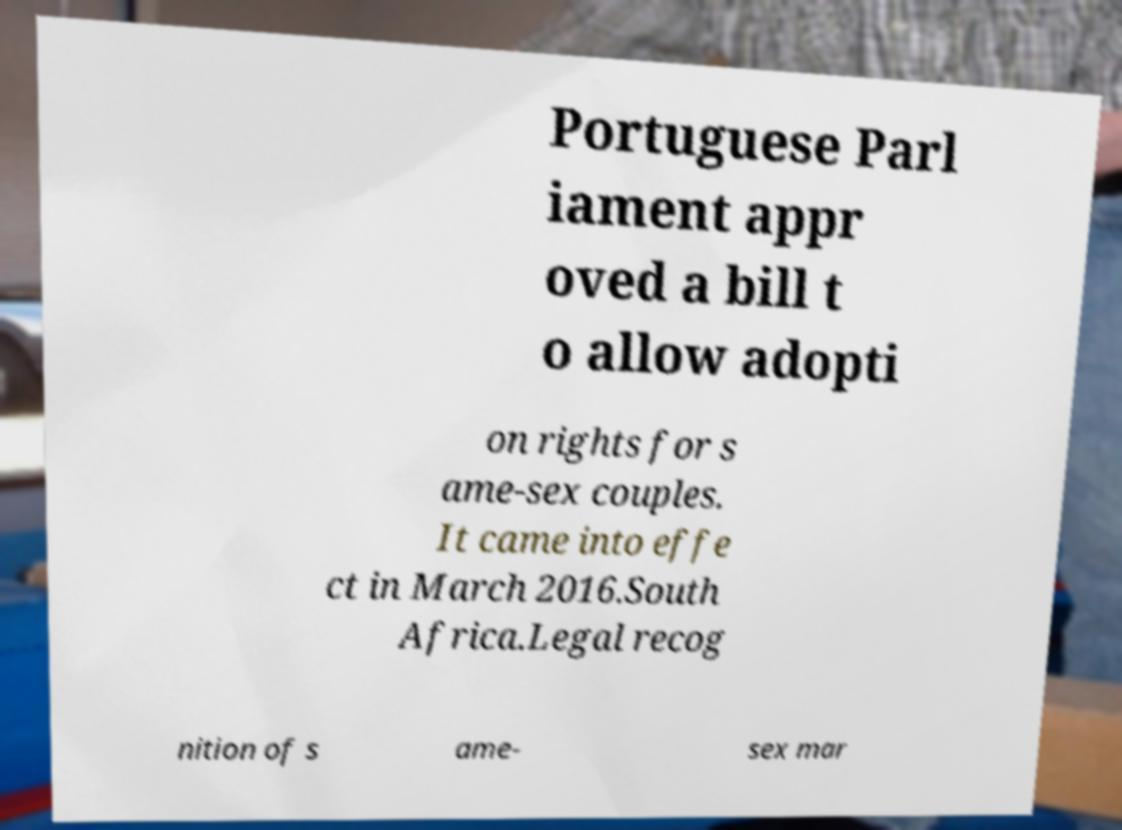Can you accurately transcribe the text from the provided image for me? Portuguese Parl iament appr oved a bill t o allow adopti on rights for s ame-sex couples. It came into effe ct in March 2016.South Africa.Legal recog nition of s ame- sex mar 